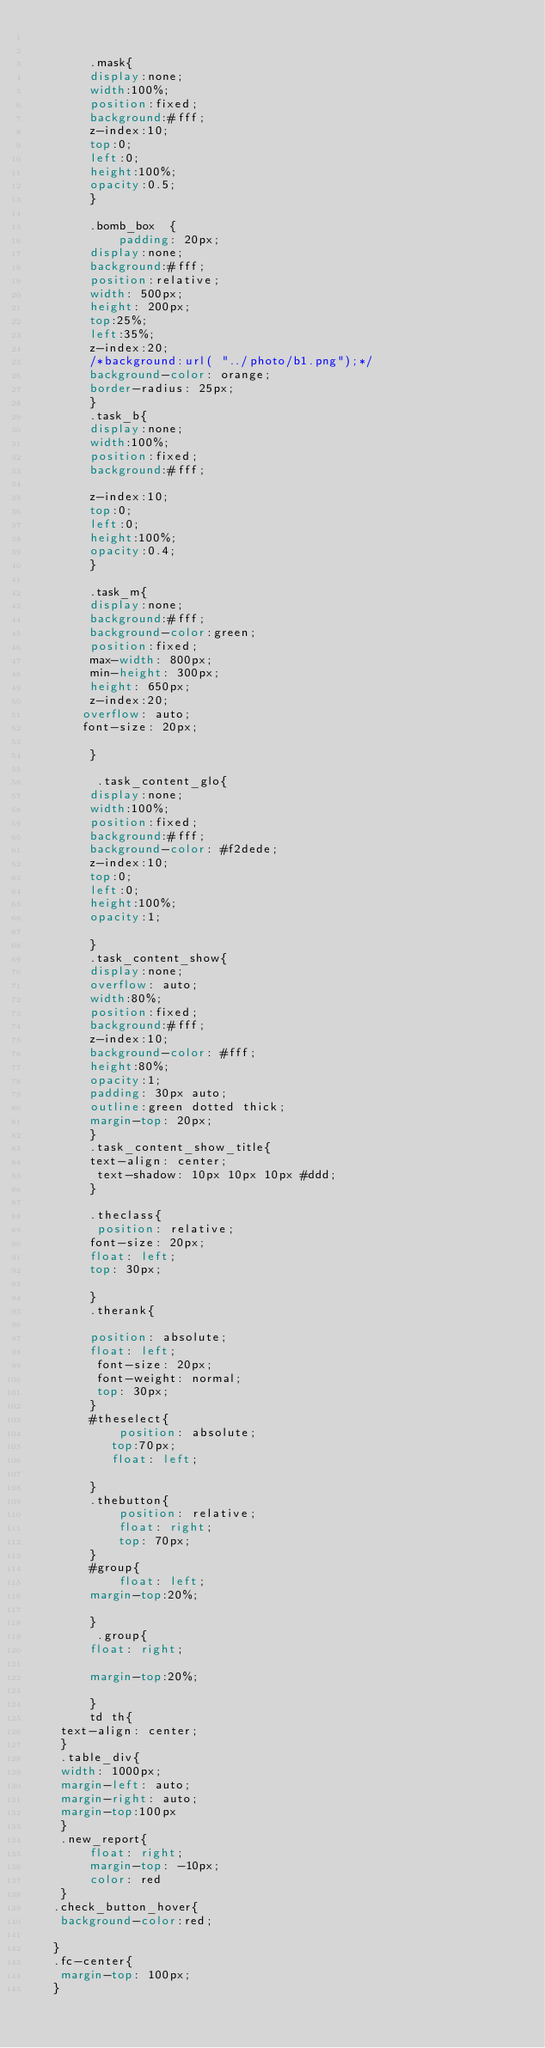Convert code to text. <code><loc_0><loc_0><loc_500><loc_500><_CSS_>

        .mask{
        display:none;
        width:100%;
        position:fixed;
        background:#fff;
        z-index:10;
        top:0;
        left:0;
        height:100%;
        opacity:0.5;
        }

        .bomb_box  {
            padding: 20px;
        display:none;
        background:#fff;
        position:relative;
        width: 500px;
        height: 200px;
        top:25%;
        left:35%;
        z-index:20;
        /*background:url( "../photo/b1.png");*/
        background-color: orange;
        border-radius: 25px;
        }
        .task_b{
        display:none;
        width:100%;
        position:fixed;
        background:#fff;

        z-index:10;
        top:0;
        left:0;
        height:100%;
        opacity:0.4;
        }

        .task_m{
        display:none;
        background:#fff;
        background-color:green;
        position:fixed;
        max-width: 800px;
        min-height: 300px;
        height: 650px;
        z-index:20;
       overflow: auto;
       font-size: 20px;

        }

         .task_content_glo{
        display:none;
        width:100%;
        position:fixed;
        background:#fff;
        background-color: #f2dede;
        z-index:10;
        top:0;
        left:0;
        height:100%;
        opacity:1;

        }
        .task_content_show{
        display:none;
        overflow: auto;
        width:80%;
        position:fixed;
        background:#fff;
        z-index:10;
        background-color: #fff;
        height:80%;
        opacity:1;
        padding: 30px auto;
        outline:green dotted thick;
        margin-top: 20px;
        }
        .task_content_show_title{
        text-align: center;
         text-shadow: 10px 10px 10px #ddd;
        }

        .theclass{
         position: relative;
        font-size: 20px;
        float: left;
        top: 30px;

        }
        .therank{

        position: absolute;
        float: left;
         font-size: 20px;
         font-weight: normal;
         top: 30px;
        }
        #theselect{
            position: absolute;
           top:70px;
           float: left;

        }
        .thebutton{
            position: relative;
            float: right;
            top: 70px;
        }
        #group{
            float: left;
        margin-top:20%;

        }
         .group{
        float: right;

        margin-top:20%;

        }
        td th{
    text-align: center;
    }
    .table_div{
    width: 1000px;
    margin-left: auto;
    margin-right: auto;
    margin-top:100px
    }
    .new_report{
        float: right;
        margin-top: -10px;
        color: red
    }
   .check_button_hover{
    background-color:red;

   }
   .fc-center{
    margin-top: 100px;
   }</code> 